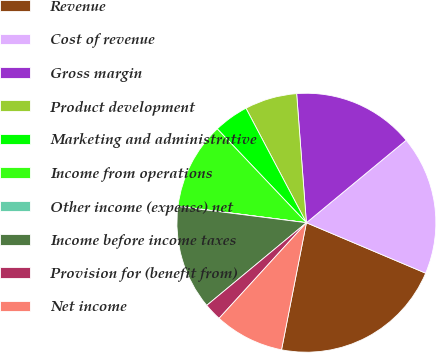Convert chart to OTSL. <chart><loc_0><loc_0><loc_500><loc_500><pie_chart><fcel>Revenue<fcel>Cost of revenue<fcel>Gross margin<fcel>Product development<fcel>Marketing and administrative<fcel>Income from operations<fcel>Other income (expense) net<fcel>Income before income taxes<fcel>Provision for (benefit from)<fcel>Net income<nl><fcel>21.71%<fcel>17.37%<fcel>15.2%<fcel>6.53%<fcel>4.36%<fcel>10.87%<fcel>0.03%<fcel>13.03%<fcel>2.2%<fcel>8.7%<nl></chart> 